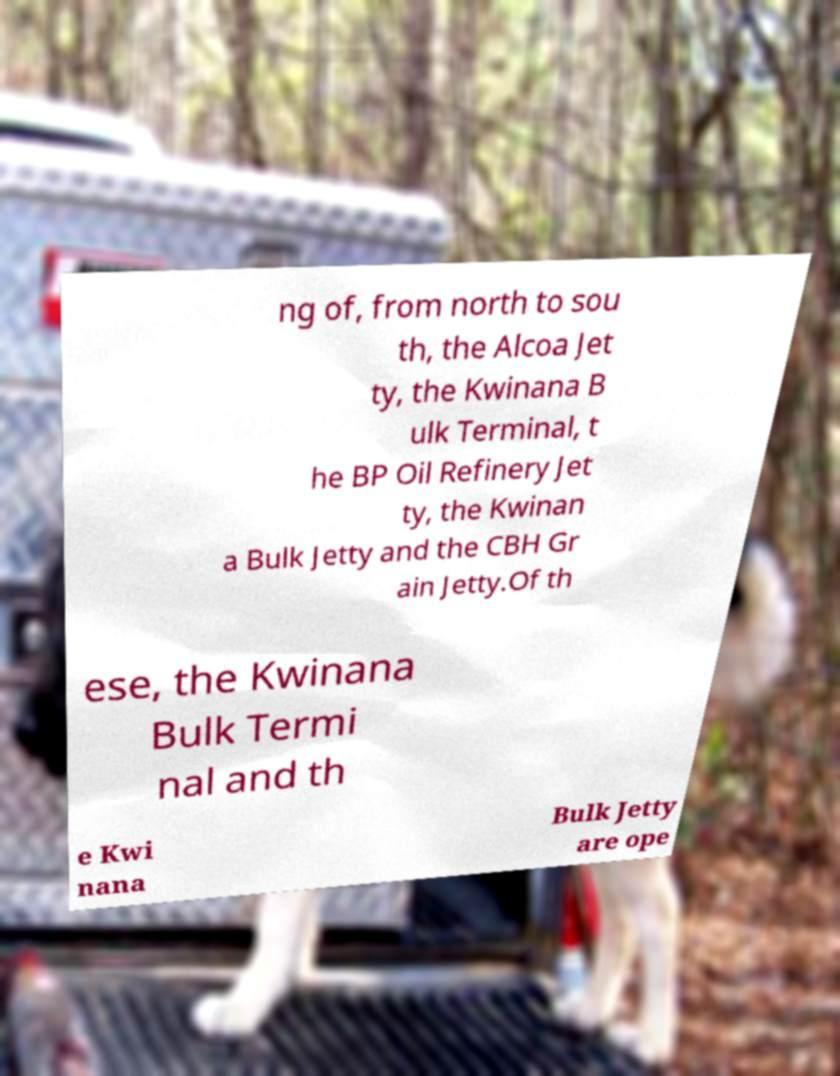What messages or text are displayed in this image? I need them in a readable, typed format. ng of, from north to sou th, the Alcoa Jet ty, the Kwinana B ulk Terminal, t he BP Oil Refinery Jet ty, the Kwinan a Bulk Jetty and the CBH Gr ain Jetty.Of th ese, the Kwinana Bulk Termi nal and th e Kwi nana Bulk Jetty are ope 